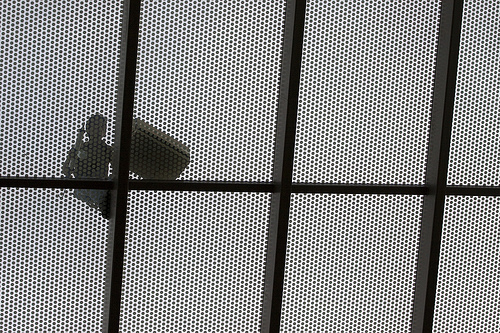<image>
Can you confirm if the man is in front of the roof? No. The man is not in front of the roof. The spatial positioning shows a different relationship between these objects. 